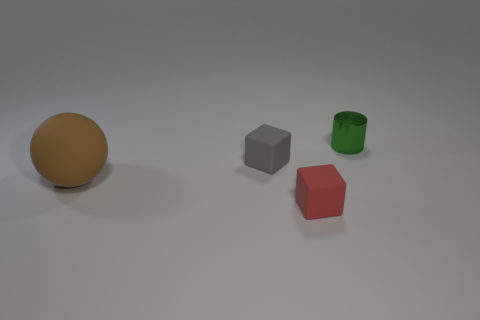Add 2 big cyan cylinders. How many objects exist? 6 Subtract all cylinders. How many objects are left? 3 Add 3 gray cubes. How many gray cubes are left? 4 Add 1 matte blocks. How many matte blocks exist? 3 Subtract 1 green cylinders. How many objects are left? 3 Subtract all tiny red things. Subtract all small red matte cubes. How many objects are left? 2 